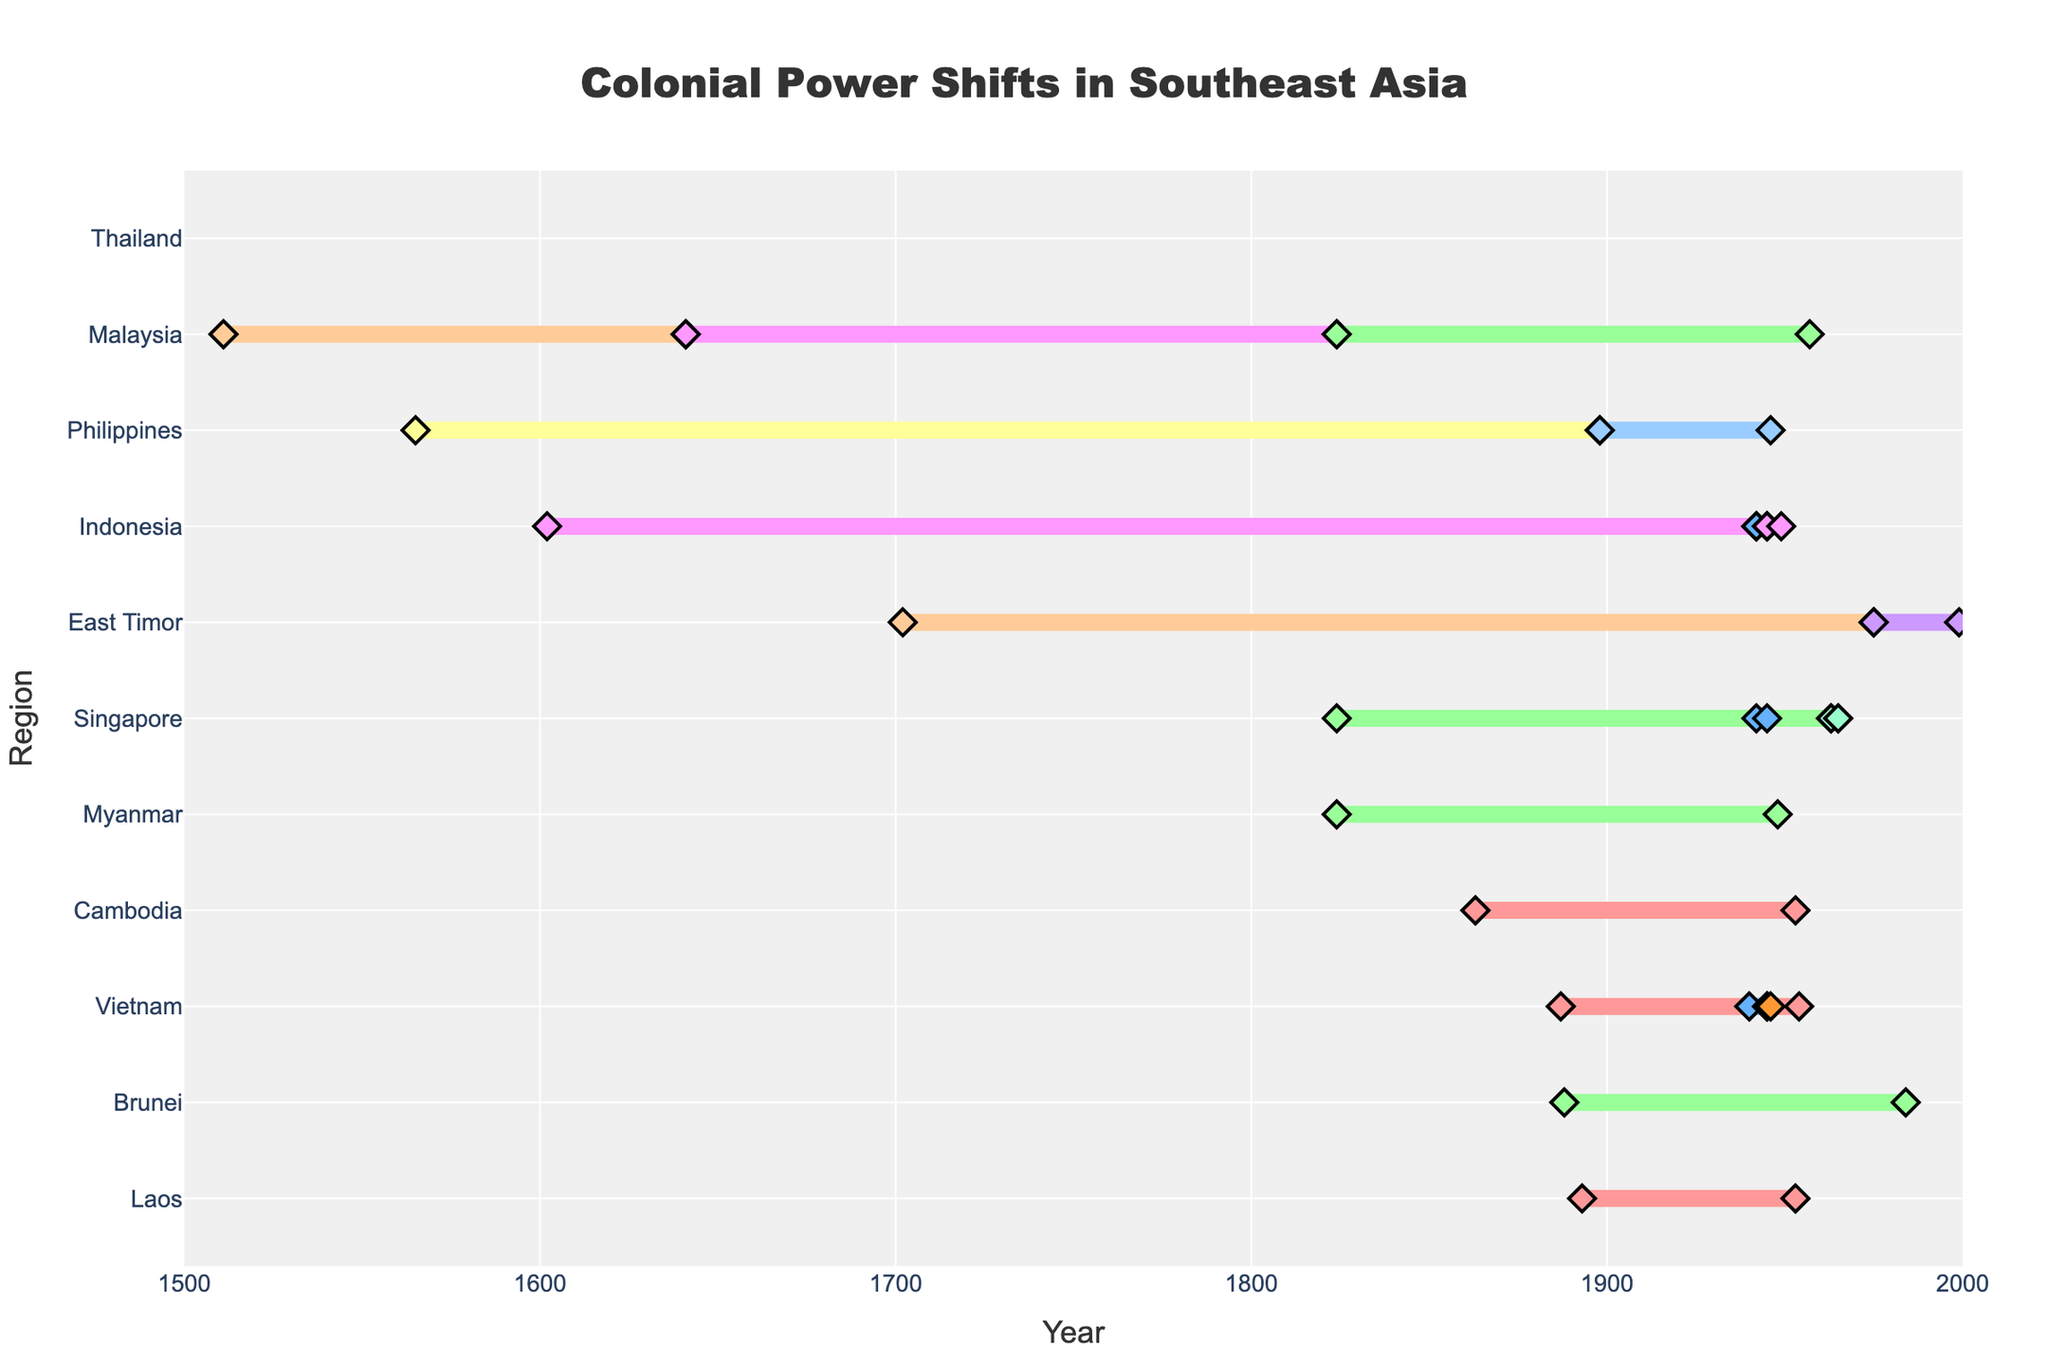What is the title of the figure? The title is typically found at the top of the figure. The title of this figure indicates the main topic or subject being visualized.
Answer: Colonial Power Shifts in Southeast Asia Which region began having colonial rule the earliest? To determine this, look at the start year for each region and identify the earliest date.
Answer: Malaysia (1511) What color represents Japanese colonial power in the figure? The colors in the plot correspond to different colonial powers. Refer to the legend or the explanations for color scales provided.
Answer: Light Blue Which colonial power ruled the Philippines right after Spain? Identify the period of Spanish control and then look for the subsequent colonial power that ruled the Philippines.
Answer: United States How many regions experienced Japanese colonial rule? Count the number of regions that have periods identified as being ruled by Japan.
Answer: 4 (Vietnam, Indonesia, Singapore, Malaysia) Which colonial power had the longest continuous rule in any single region? Search for the longest duration between start and end years for each colonial power in a single region.
Answer: Portugal (East Timor, 1702-1975) What is the total duration of colonial rule over Malaysia by all colonial powers combined? Sum the durations of all colonial periods for Malaysia (i.e., Portugal, Netherlands, Great Britain).
Answer: 1511-1641 (130 years), 1641-1824 (183 years), 1824-1957 (133 years) = 446 years Which region had the shortest duration of colonial power? Determine the duration of each colonial period and identify the shortest one.
Answer: Vietnam (China, 1945-1946) Which region remained the longest under British rule? Compare the periods of British rule across different regions to find the longest one.
Answer: Brunei (1888-1984, 96 years) How many regions experienced multiple colonial powers? Identify regions that had more than one colonial power listed.
Answer: 7 (Vietnam, Malaysia, Philippines, Indonesia, East Timor, Singapore, Brunei) 